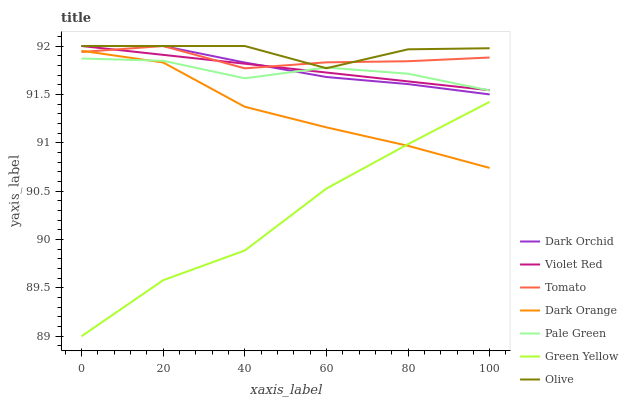Does Green Yellow have the minimum area under the curve?
Answer yes or no. Yes. Does Olive have the maximum area under the curve?
Answer yes or no. Yes. Does Dark Orange have the minimum area under the curve?
Answer yes or no. No. Does Dark Orange have the maximum area under the curve?
Answer yes or no. No. Is Violet Red the smoothest?
Answer yes or no. Yes. Is Olive the roughest?
Answer yes or no. Yes. Is Dark Orange the smoothest?
Answer yes or no. No. Is Dark Orange the roughest?
Answer yes or no. No. Does Green Yellow have the lowest value?
Answer yes or no. Yes. Does Dark Orange have the lowest value?
Answer yes or no. No. Does Olive have the highest value?
Answer yes or no. Yes. Does Dark Orange have the highest value?
Answer yes or no. No. Is Green Yellow less than Olive?
Answer yes or no. Yes. Is Tomato greater than Pale Green?
Answer yes or no. Yes. Does Tomato intersect Olive?
Answer yes or no. Yes. Is Tomato less than Olive?
Answer yes or no. No. Is Tomato greater than Olive?
Answer yes or no. No. Does Green Yellow intersect Olive?
Answer yes or no. No. 